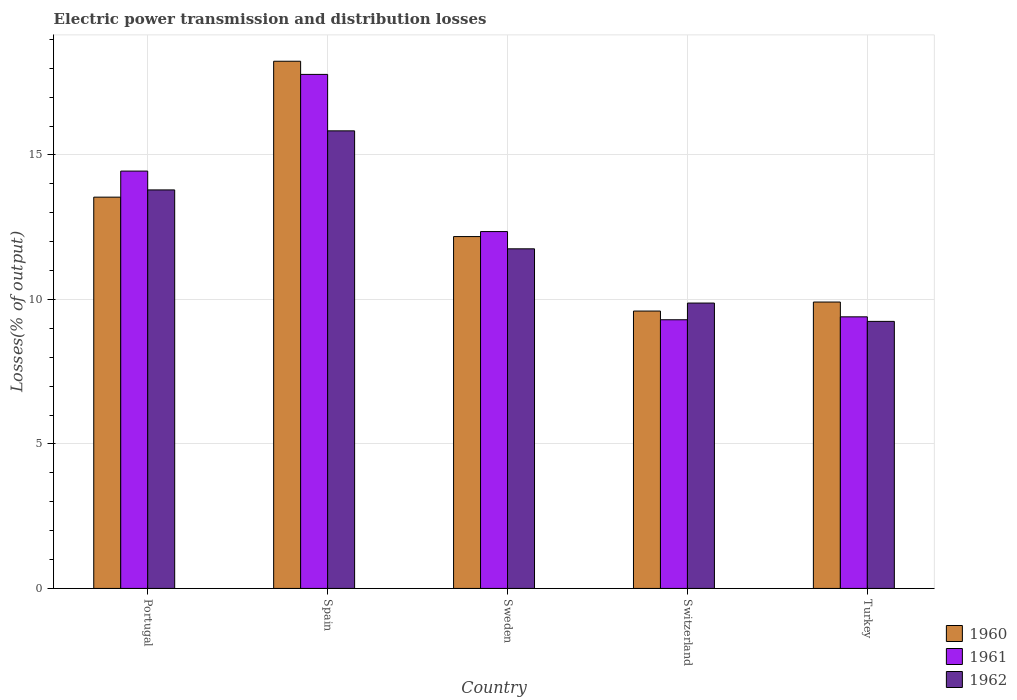How many different coloured bars are there?
Offer a very short reply. 3. How many groups of bars are there?
Give a very brief answer. 5. Are the number of bars per tick equal to the number of legend labels?
Keep it short and to the point. Yes. How many bars are there on the 1st tick from the left?
Provide a succinct answer. 3. What is the label of the 2nd group of bars from the left?
Your response must be concise. Spain. In how many cases, is the number of bars for a given country not equal to the number of legend labels?
Your answer should be very brief. 0. What is the electric power transmission and distribution losses in 1960 in Switzerland?
Provide a short and direct response. 9.6. Across all countries, what is the maximum electric power transmission and distribution losses in 1962?
Ensure brevity in your answer.  15.83. Across all countries, what is the minimum electric power transmission and distribution losses in 1961?
Offer a very short reply. 9.3. In which country was the electric power transmission and distribution losses in 1962 maximum?
Ensure brevity in your answer.  Spain. In which country was the electric power transmission and distribution losses in 1960 minimum?
Your answer should be compact. Switzerland. What is the total electric power transmission and distribution losses in 1962 in the graph?
Give a very brief answer. 60.5. What is the difference between the electric power transmission and distribution losses in 1961 in Portugal and that in Turkey?
Offer a terse response. 5.04. What is the difference between the electric power transmission and distribution losses in 1961 in Portugal and the electric power transmission and distribution losses in 1960 in Sweden?
Your answer should be compact. 2.27. What is the average electric power transmission and distribution losses in 1961 per country?
Offer a very short reply. 12.66. What is the difference between the electric power transmission and distribution losses of/in 1961 and electric power transmission and distribution losses of/in 1960 in Turkey?
Provide a succinct answer. -0.51. In how many countries, is the electric power transmission and distribution losses in 1962 greater than 2 %?
Provide a succinct answer. 5. What is the ratio of the electric power transmission and distribution losses in 1961 in Spain to that in Turkey?
Offer a terse response. 1.89. What is the difference between the highest and the second highest electric power transmission and distribution losses in 1962?
Give a very brief answer. -2.04. What is the difference between the highest and the lowest electric power transmission and distribution losses in 1961?
Offer a terse response. 8.49. In how many countries, is the electric power transmission and distribution losses in 1961 greater than the average electric power transmission and distribution losses in 1961 taken over all countries?
Your response must be concise. 2. What does the 1st bar from the right in Switzerland represents?
Offer a terse response. 1962. How many bars are there?
Your answer should be very brief. 15. What is the difference between two consecutive major ticks on the Y-axis?
Your response must be concise. 5. Are the values on the major ticks of Y-axis written in scientific E-notation?
Your answer should be compact. No. How many legend labels are there?
Ensure brevity in your answer.  3. What is the title of the graph?
Your answer should be compact. Electric power transmission and distribution losses. What is the label or title of the Y-axis?
Your answer should be very brief. Losses(% of output). What is the Losses(% of output) of 1960 in Portugal?
Offer a very short reply. 13.54. What is the Losses(% of output) of 1961 in Portugal?
Provide a succinct answer. 14.44. What is the Losses(% of output) in 1962 in Portugal?
Ensure brevity in your answer.  13.79. What is the Losses(% of output) of 1960 in Spain?
Give a very brief answer. 18.24. What is the Losses(% of output) in 1961 in Spain?
Give a very brief answer. 17.79. What is the Losses(% of output) in 1962 in Spain?
Your answer should be compact. 15.83. What is the Losses(% of output) of 1960 in Sweden?
Give a very brief answer. 12.18. What is the Losses(% of output) in 1961 in Sweden?
Offer a terse response. 12.35. What is the Losses(% of output) in 1962 in Sweden?
Your answer should be very brief. 11.75. What is the Losses(% of output) of 1960 in Switzerland?
Ensure brevity in your answer.  9.6. What is the Losses(% of output) of 1961 in Switzerland?
Provide a succinct answer. 9.3. What is the Losses(% of output) of 1962 in Switzerland?
Make the answer very short. 9.88. What is the Losses(% of output) of 1960 in Turkey?
Provide a succinct answer. 9.91. What is the Losses(% of output) in 1961 in Turkey?
Your answer should be compact. 9.4. What is the Losses(% of output) of 1962 in Turkey?
Keep it short and to the point. 9.24. Across all countries, what is the maximum Losses(% of output) in 1960?
Offer a terse response. 18.24. Across all countries, what is the maximum Losses(% of output) in 1961?
Ensure brevity in your answer.  17.79. Across all countries, what is the maximum Losses(% of output) in 1962?
Your answer should be very brief. 15.83. Across all countries, what is the minimum Losses(% of output) of 1960?
Provide a succinct answer. 9.6. Across all countries, what is the minimum Losses(% of output) of 1961?
Give a very brief answer. 9.3. Across all countries, what is the minimum Losses(% of output) in 1962?
Give a very brief answer. 9.24. What is the total Losses(% of output) in 1960 in the graph?
Give a very brief answer. 63.47. What is the total Losses(% of output) of 1961 in the graph?
Give a very brief answer. 63.28. What is the total Losses(% of output) in 1962 in the graph?
Provide a succinct answer. 60.5. What is the difference between the Losses(% of output) of 1960 in Portugal and that in Spain?
Your answer should be compact. -4.7. What is the difference between the Losses(% of output) in 1961 in Portugal and that in Spain?
Your answer should be very brief. -3.35. What is the difference between the Losses(% of output) in 1962 in Portugal and that in Spain?
Ensure brevity in your answer.  -2.04. What is the difference between the Losses(% of output) of 1960 in Portugal and that in Sweden?
Offer a very short reply. 1.36. What is the difference between the Losses(% of output) in 1961 in Portugal and that in Sweden?
Keep it short and to the point. 2.09. What is the difference between the Losses(% of output) in 1962 in Portugal and that in Sweden?
Offer a terse response. 2.04. What is the difference between the Losses(% of output) in 1960 in Portugal and that in Switzerland?
Your answer should be very brief. 3.94. What is the difference between the Losses(% of output) in 1961 in Portugal and that in Switzerland?
Your answer should be compact. 5.14. What is the difference between the Losses(% of output) of 1962 in Portugal and that in Switzerland?
Offer a terse response. 3.92. What is the difference between the Losses(% of output) in 1960 in Portugal and that in Turkey?
Your answer should be very brief. 3.63. What is the difference between the Losses(% of output) of 1961 in Portugal and that in Turkey?
Your response must be concise. 5.04. What is the difference between the Losses(% of output) of 1962 in Portugal and that in Turkey?
Your answer should be compact. 4.55. What is the difference between the Losses(% of output) in 1960 in Spain and that in Sweden?
Offer a very short reply. 6.07. What is the difference between the Losses(% of output) of 1961 in Spain and that in Sweden?
Offer a terse response. 5.44. What is the difference between the Losses(% of output) of 1962 in Spain and that in Sweden?
Make the answer very short. 4.08. What is the difference between the Losses(% of output) of 1960 in Spain and that in Switzerland?
Provide a short and direct response. 8.65. What is the difference between the Losses(% of output) of 1961 in Spain and that in Switzerland?
Offer a very short reply. 8.49. What is the difference between the Losses(% of output) of 1962 in Spain and that in Switzerland?
Ensure brevity in your answer.  5.96. What is the difference between the Losses(% of output) of 1960 in Spain and that in Turkey?
Keep it short and to the point. 8.33. What is the difference between the Losses(% of output) of 1961 in Spain and that in Turkey?
Your answer should be compact. 8.39. What is the difference between the Losses(% of output) of 1962 in Spain and that in Turkey?
Your answer should be compact. 6.59. What is the difference between the Losses(% of output) of 1960 in Sweden and that in Switzerland?
Your answer should be very brief. 2.58. What is the difference between the Losses(% of output) in 1961 in Sweden and that in Switzerland?
Your answer should be compact. 3.05. What is the difference between the Losses(% of output) of 1962 in Sweden and that in Switzerland?
Provide a short and direct response. 1.88. What is the difference between the Losses(% of output) of 1960 in Sweden and that in Turkey?
Offer a terse response. 2.27. What is the difference between the Losses(% of output) of 1961 in Sweden and that in Turkey?
Provide a short and direct response. 2.95. What is the difference between the Losses(% of output) in 1962 in Sweden and that in Turkey?
Offer a very short reply. 2.51. What is the difference between the Losses(% of output) in 1960 in Switzerland and that in Turkey?
Your response must be concise. -0.31. What is the difference between the Losses(% of output) of 1961 in Switzerland and that in Turkey?
Offer a very short reply. -0.1. What is the difference between the Losses(% of output) of 1962 in Switzerland and that in Turkey?
Provide a succinct answer. 0.63. What is the difference between the Losses(% of output) in 1960 in Portugal and the Losses(% of output) in 1961 in Spain?
Give a very brief answer. -4.25. What is the difference between the Losses(% of output) in 1960 in Portugal and the Losses(% of output) in 1962 in Spain?
Offer a terse response. -2.29. What is the difference between the Losses(% of output) of 1961 in Portugal and the Losses(% of output) of 1962 in Spain?
Provide a succinct answer. -1.39. What is the difference between the Losses(% of output) in 1960 in Portugal and the Losses(% of output) in 1961 in Sweden?
Your answer should be very brief. 1.19. What is the difference between the Losses(% of output) of 1960 in Portugal and the Losses(% of output) of 1962 in Sweden?
Offer a terse response. 1.79. What is the difference between the Losses(% of output) of 1961 in Portugal and the Losses(% of output) of 1962 in Sweden?
Provide a short and direct response. 2.69. What is the difference between the Losses(% of output) of 1960 in Portugal and the Losses(% of output) of 1961 in Switzerland?
Ensure brevity in your answer.  4.24. What is the difference between the Losses(% of output) in 1960 in Portugal and the Losses(% of output) in 1962 in Switzerland?
Your answer should be compact. 3.66. What is the difference between the Losses(% of output) of 1961 in Portugal and the Losses(% of output) of 1962 in Switzerland?
Keep it short and to the point. 4.57. What is the difference between the Losses(% of output) in 1960 in Portugal and the Losses(% of output) in 1961 in Turkey?
Offer a very short reply. 4.14. What is the difference between the Losses(% of output) in 1960 in Portugal and the Losses(% of output) in 1962 in Turkey?
Give a very brief answer. 4.3. What is the difference between the Losses(% of output) in 1961 in Portugal and the Losses(% of output) in 1962 in Turkey?
Your response must be concise. 5.2. What is the difference between the Losses(% of output) of 1960 in Spain and the Losses(% of output) of 1961 in Sweden?
Your answer should be very brief. 5.89. What is the difference between the Losses(% of output) in 1960 in Spain and the Losses(% of output) in 1962 in Sweden?
Provide a short and direct response. 6.49. What is the difference between the Losses(% of output) of 1961 in Spain and the Losses(% of output) of 1962 in Sweden?
Ensure brevity in your answer.  6.04. What is the difference between the Losses(% of output) in 1960 in Spain and the Losses(% of output) in 1961 in Switzerland?
Ensure brevity in your answer.  8.95. What is the difference between the Losses(% of output) in 1960 in Spain and the Losses(% of output) in 1962 in Switzerland?
Make the answer very short. 8.37. What is the difference between the Losses(% of output) in 1961 in Spain and the Losses(% of output) in 1962 in Switzerland?
Provide a short and direct response. 7.91. What is the difference between the Losses(% of output) of 1960 in Spain and the Losses(% of output) of 1961 in Turkey?
Provide a short and direct response. 8.85. What is the difference between the Losses(% of output) of 1960 in Spain and the Losses(% of output) of 1962 in Turkey?
Ensure brevity in your answer.  9. What is the difference between the Losses(% of output) in 1961 in Spain and the Losses(% of output) in 1962 in Turkey?
Give a very brief answer. 8.55. What is the difference between the Losses(% of output) in 1960 in Sweden and the Losses(% of output) in 1961 in Switzerland?
Keep it short and to the point. 2.88. What is the difference between the Losses(% of output) of 1960 in Sweden and the Losses(% of output) of 1962 in Switzerland?
Your response must be concise. 2.3. What is the difference between the Losses(% of output) of 1961 in Sweden and the Losses(% of output) of 1962 in Switzerland?
Offer a terse response. 2.47. What is the difference between the Losses(% of output) in 1960 in Sweden and the Losses(% of output) in 1961 in Turkey?
Ensure brevity in your answer.  2.78. What is the difference between the Losses(% of output) of 1960 in Sweden and the Losses(% of output) of 1962 in Turkey?
Offer a terse response. 2.94. What is the difference between the Losses(% of output) in 1961 in Sweden and the Losses(% of output) in 1962 in Turkey?
Ensure brevity in your answer.  3.11. What is the difference between the Losses(% of output) of 1960 in Switzerland and the Losses(% of output) of 1961 in Turkey?
Give a very brief answer. 0.2. What is the difference between the Losses(% of output) of 1960 in Switzerland and the Losses(% of output) of 1962 in Turkey?
Offer a terse response. 0.36. What is the difference between the Losses(% of output) in 1961 in Switzerland and the Losses(% of output) in 1962 in Turkey?
Ensure brevity in your answer.  0.06. What is the average Losses(% of output) in 1960 per country?
Ensure brevity in your answer.  12.69. What is the average Losses(% of output) in 1961 per country?
Keep it short and to the point. 12.66. What is the average Losses(% of output) in 1962 per country?
Keep it short and to the point. 12.1. What is the difference between the Losses(% of output) of 1960 and Losses(% of output) of 1961 in Portugal?
Your answer should be very brief. -0.9. What is the difference between the Losses(% of output) in 1960 and Losses(% of output) in 1962 in Portugal?
Your response must be concise. -0.25. What is the difference between the Losses(% of output) of 1961 and Losses(% of output) of 1962 in Portugal?
Ensure brevity in your answer.  0.65. What is the difference between the Losses(% of output) in 1960 and Losses(% of output) in 1961 in Spain?
Keep it short and to the point. 0.46. What is the difference between the Losses(% of output) in 1960 and Losses(% of output) in 1962 in Spain?
Your response must be concise. 2.41. What is the difference between the Losses(% of output) in 1961 and Losses(% of output) in 1962 in Spain?
Offer a very short reply. 1.95. What is the difference between the Losses(% of output) in 1960 and Losses(% of output) in 1961 in Sweden?
Provide a short and direct response. -0.17. What is the difference between the Losses(% of output) in 1960 and Losses(% of output) in 1962 in Sweden?
Your answer should be very brief. 0.42. What is the difference between the Losses(% of output) of 1961 and Losses(% of output) of 1962 in Sweden?
Your response must be concise. 0.6. What is the difference between the Losses(% of output) of 1960 and Losses(% of output) of 1961 in Switzerland?
Your answer should be very brief. 0.3. What is the difference between the Losses(% of output) in 1960 and Losses(% of output) in 1962 in Switzerland?
Provide a short and direct response. -0.28. What is the difference between the Losses(% of output) in 1961 and Losses(% of output) in 1962 in Switzerland?
Make the answer very short. -0.58. What is the difference between the Losses(% of output) in 1960 and Losses(% of output) in 1961 in Turkey?
Offer a terse response. 0.51. What is the difference between the Losses(% of output) of 1960 and Losses(% of output) of 1962 in Turkey?
Your answer should be compact. 0.67. What is the difference between the Losses(% of output) of 1961 and Losses(% of output) of 1962 in Turkey?
Your answer should be compact. 0.16. What is the ratio of the Losses(% of output) of 1960 in Portugal to that in Spain?
Offer a terse response. 0.74. What is the ratio of the Losses(% of output) of 1961 in Portugal to that in Spain?
Your answer should be very brief. 0.81. What is the ratio of the Losses(% of output) of 1962 in Portugal to that in Spain?
Keep it short and to the point. 0.87. What is the ratio of the Losses(% of output) of 1960 in Portugal to that in Sweden?
Provide a succinct answer. 1.11. What is the ratio of the Losses(% of output) of 1961 in Portugal to that in Sweden?
Keep it short and to the point. 1.17. What is the ratio of the Losses(% of output) in 1962 in Portugal to that in Sweden?
Give a very brief answer. 1.17. What is the ratio of the Losses(% of output) of 1960 in Portugal to that in Switzerland?
Give a very brief answer. 1.41. What is the ratio of the Losses(% of output) in 1961 in Portugal to that in Switzerland?
Ensure brevity in your answer.  1.55. What is the ratio of the Losses(% of output) of 1962 in Portugal to that in Switzerland?
Offer a very short reply. 1.4. What is the ratio of the Losses(% of output) of 1960 in Portugal to that in Turkey?
Your answer should be compact. 1.37. What is the ratio of the Losses(% of output) in 1961 in Portugal to that in Turkey?
Ensure brevity in your answer.  1.54. What is the ratio of the Losses(% of output) in 1962 in Portugal to that in Turkey?
Provide a succinct answer. 1.49. What is the ratio of the Losses(% of output) in 1960 in Spain to that in Sweden?
Make the answer very short. 1.5. What is the ratio of the Losses(% of output) in 1961 in Spain to that in Sweden?
Provide a short and direct response. 1.44. What is the ratio of the Losses(% of output) in 1962 in Spain to that in Sweden?
Ensure brevity in your answer.  1.35. What is the ratio of the Losses(% of output) in 1960 in Spain to that in Switzerland?
Provide a succinct answer. 1.9. What is the ratio of the Losses(% of output) of 1961 in Spain to that in Switzerland?
Your answer should be compact. 1.91. What is the ratio of the Losses(% of output) of 1962 in Spain to that in Switzerland?
Ensure brevity in your answer.  1.6. What is the ratio of the Losses(% of output) of 1960 in Spain to that in Turkey?
Provide a short and direct response. 1.84. What is the ratio of the Losses(% of output) of 1961 in Spain to that in Turkey?
Your answer should be compact. 1.89. What is the ratio of the Losses(% of output) of 1962 in Spain to that in Turkey?
Make the answer very short. 1.71. What is the ratio of the Losses(% of output) in 1960 in Sweden to that in Switzerland?
Give a very brief answer. 1.27. What is the ratio of the Losses(% of output) in 1961 in Sweden to that in Switzerland?
Your answer should be very brief. 1.33. What is the ratio of the Losses(% of output) of 1962 in Sweden to that in Switzerland?
Make the answer very short. 1.19. What is the ratio of the Losses(% of output) in 1960 in Sweden to that in Turkey?
Keep it short and to the point. 1.23. What is the ratio of the Losses(% of output) of 1961 in Sweden to that in Turkey?
Provide a short and direct response. 1.31. What is the ratio of the Losses(% of output) of 1962 in Sweden to that in Turkey?
Make the answer very short. 1.27. What is the ratio of the Losses(% of output) of 1960 in Switzerland to that in Turkey?
Offer a terse response. 0.97. What is the ratio of the Losses(% of output) of 1961 in Switzerland to that in Turkey?
Ensure brevity in your answer.  0.99. What is the ratio of the Losses(% of output) of 1962 in Switzerland to that in Turkey?
Give a very brief answer. 1.07. What is the difference between the highest and the second highest Losses(% of output) in 1960?
Provide a succinct answer. 4.7. What is the difference between the highest and the second highest Losses(% of output) of 1961?
Make the answer very short. 3.35. What is the difference between the highest and the second highest Losses(% of output) of 1962?
Keep it short and to the point. 2.04. What is the difference between the highest and the lowest Losses(% of output) of 1960?
Provide a short and direct response. 8.65. What is the difference between the highest and the lowest Losses(% of output) of 1961?
Give a very brief answer. 8.49. What is the difference between the highest and the lowest Losses(% of output) of 1962?
Provide a succinct answer. 6.59. 